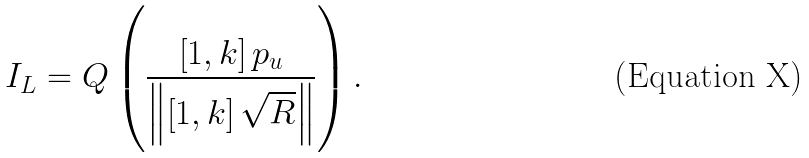Convert formula to latex. <formula><loc_0><loc_0><loc_500><loc_500>{ I _ { L } } = Q \left ( { \frac { { \left [ { 1 , k } \right ] { { p } _ { u } } } } { { \left \| { \left [ { 1 , k } \right ] \sqrt { R } } \right \| } } } \right ) .</formula> 